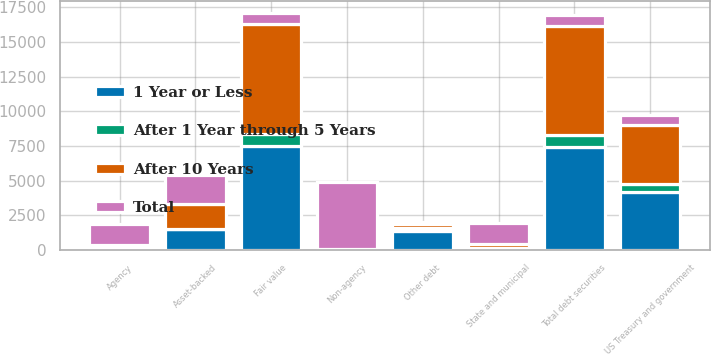Convert chart to OTSL. <chart><loc_0><loc_0><loc_500><loc_500><stacked_bar_chart><ecel><fcel>US Treasury and government<fcel>Agency<fcel>Non-agency<fcel>Asset-backed<fcel>State and municipal<fcel>Other debt<fcel>Total debt securities<fcel>Fair value<nl><fcel>After 1 Year through 5 Years<fcel>586<fcel>22<fcel>50<fcel>9<fcel>1<fcel>186<fcel>854<fcel>861<nl><fcel>1 Year or Less<fcel>4172<fcel>109<fcel>28<fcel>1526<fcel>127<fcel>1377<fcel>7441<fcel>7497<nl><fcel>After 10 Years<fcel>4234<fcel>232<fcel>8<fcel>1787<fcel>336<fcel>289<fcel>7872<fcel>7926<nl><fcel>Total<fcel>772<fcel>1554<fcel>4816<fcel>2095<fcel>1518<fcel>155<fcel>813<fcel>813<nl></chart> 